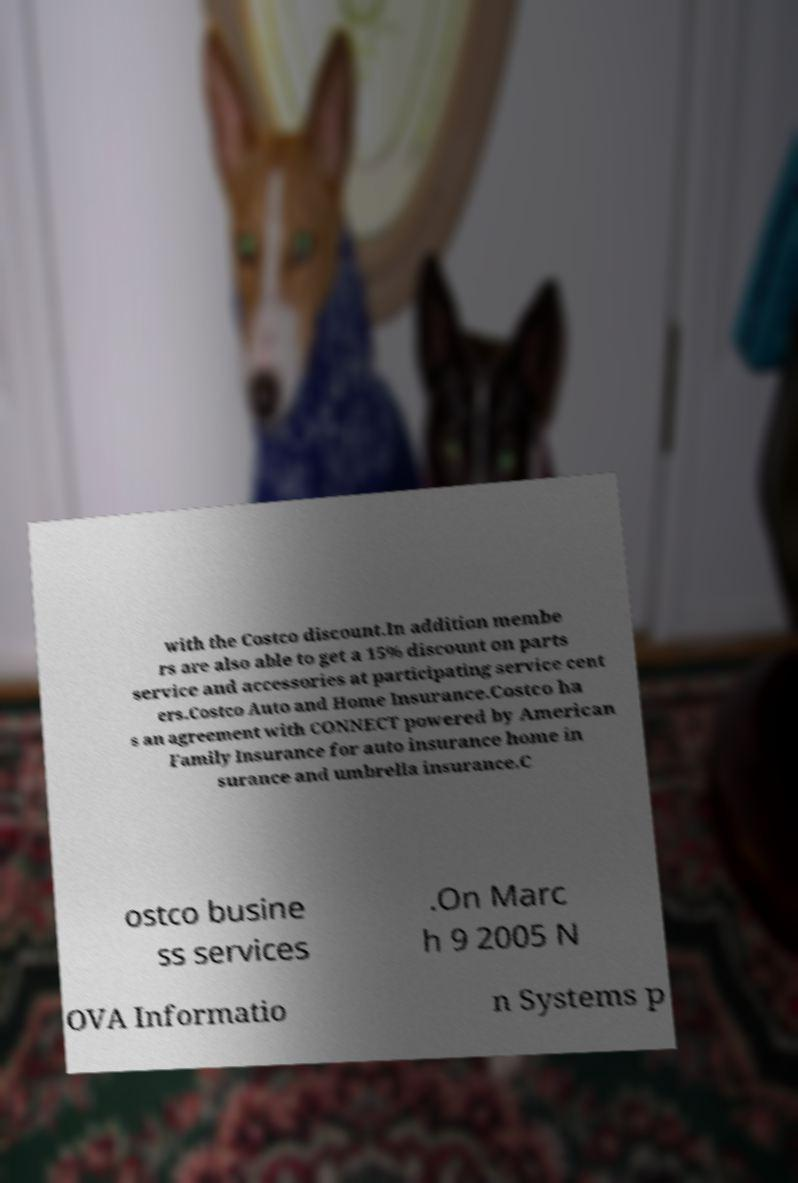There's text embedded in this image that I need extracted. Can you transcribe it verbatim? with the Costco discount.In addition membe rs are also able to get a 15% discount on parts service and accessories at participating service cent ers.Costco Auto and Home Insurance.Costco ha s an agreement with CONNECT powered by American Family Insurance for auto insurance home in surance and umbrella insurance.C ostco busine ss services .On Marc h 9 2005 N OVA Informatio n Systems p 